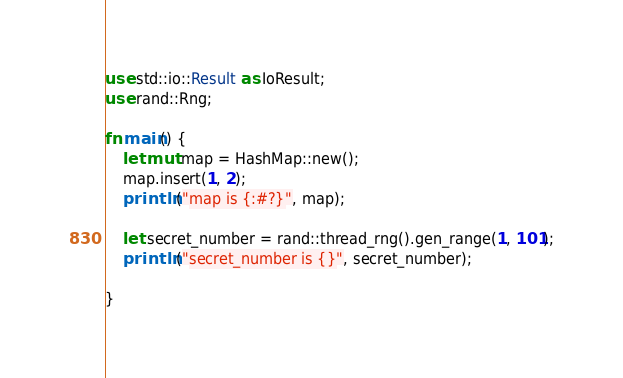<code> <loc_0><loc_0><loc_500><loc_500><_Rust_>use std::io::Result as IoResult;
use rand::Rng;

fn main() {
    let mut map = HashMap::new();
    map.insert(1, 2);
    println!("map is {:#?}", map);

    let secret_number = rand::thread_rng().gen_range(1, 101);
    println!("secret_number is {}", secret_number);
    
}
</code> 